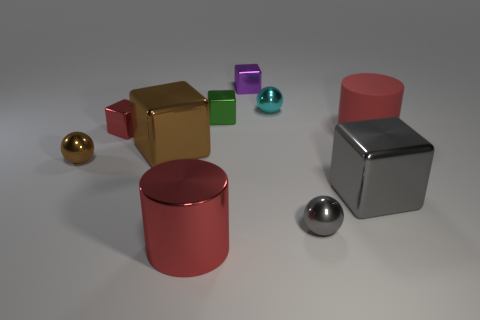Is the size of the green thing the same as the metallic sphere in front of the gray metallic block?
Give a very brief answer. Yes. What is the color of the cylinder that is on the left side of the large cube on the right side of the small sphere behind the small green shiny object?
Ensure brevity in your answer.  Red. The rubber cylinder has what color?
Your response must be concise. Red. Are there more cyan metallic spheres behind the cyan ball than large gray things that are behind the gray cube?
Give a very brief answer. No. There is a tiny red thing; does it have the same shape as the brown thing that is on the right side of the red shiny block?
Make the answer very short. Yes. There is a shiny cube that is in front of the small brown thing; is its size the same as the red thing right of the purple block?
Ensure brevity in your answer.  Yes. There is a small shiny thing that is in front of the brown shiny thing that is to the left of the brown shiny block; are there any cyan metallic objects that are behind it?
Offer a terse response. Yes. Is the number of big gray cubes behind the matte cylinder less than the number of small metallic cubes in front of the green metal cube?
Offer a terse response. Yes. What shape is the large red thing that is made of the same material as the tiny cyan object?
Provide a short and direct response. Cylinder. What size is the metallic ball that is to the left of the tiny green object behind the large shiny thing that is behind the brown metallic ball?
Offer a very short reply. Small. 